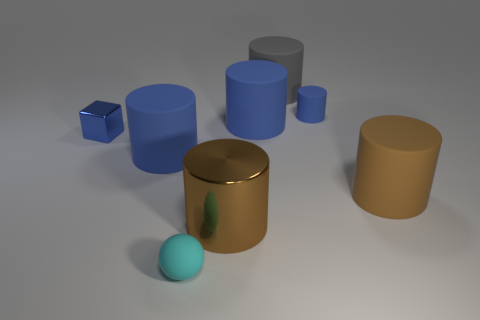What is the color of the small sphere that is the same material as the big gray cylinder?
Offer a very short reply. Cyan. What number of tiny things are in front of the small rubber object that is right of the thing behind the small blue rubber object?
Offer a very short reply. 2. There is a small object that is the same color as the tiny matte cylinder; what is its material?
Offer a terse response. Metal. Is there anything else that is the same shape as the big brown rubber object?
Give a very brief answer. Yes. What number of objects are rubber things behind the small cyan object or large green rubber blocks?
Offer a very short reply. 5. Does the shiny thing that is in front of the large brown rubber cylinder have the same color as the tiny shiny block?
Provide a succinct answer. No. There is a big rubber thing that is to the left of the brown cylinder that is on the left side of the large gray matte cylinder; what shape is it?
Offer a very short reply. Cylinder. Is the number of gray objects on the right side of the rubber sphere less than the number of matte cylinders to the right of the gray matte object?
Give a very brief answer. Yes. The other brown object that is the same shape as the large metal thing is what size?
Give a very brief answer. Large. Are there any other things that are the same size as the blue metal object?
Give a very brief answer. Yes. 